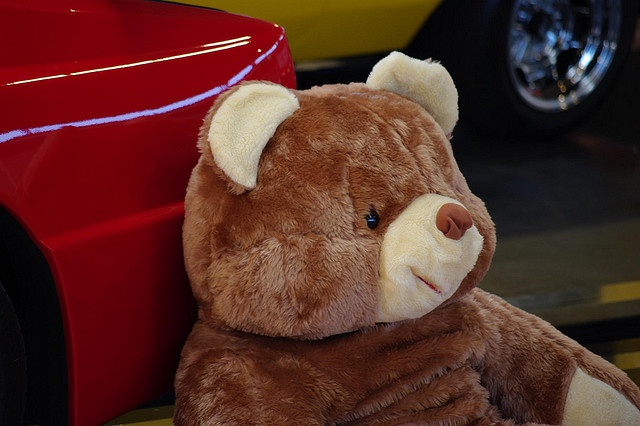Describe the objects in this image and their specific colors. I can see teddy bear in maroon, gray, brown, and black tones, car in maroon, black, and violet tones, and car in maroon, black, olive, and navy tones in this image. 